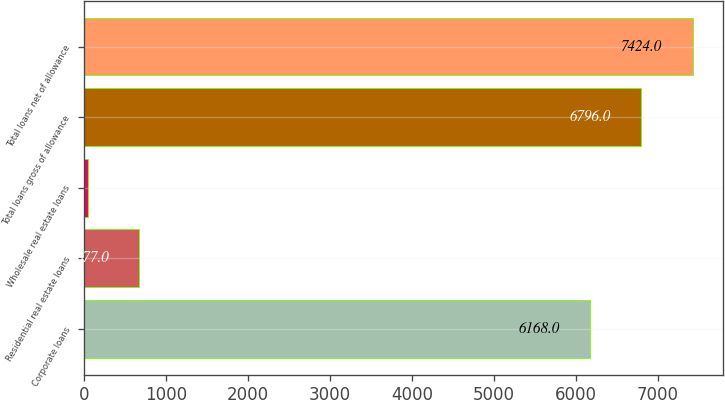<chart> <loc_0><loc_0><loc_500><loc_500><bar_chart><fcel>Corporate loans<fcel>Residential real estate loans<fcel>Wholesale real estate loans<fcel>Total loans gross of allowance<fcel>Total loans net of allowance<nl><fcel>6168<fcel>677<fcel>49<fcel>6796<fcel>7424<nl></chart> 